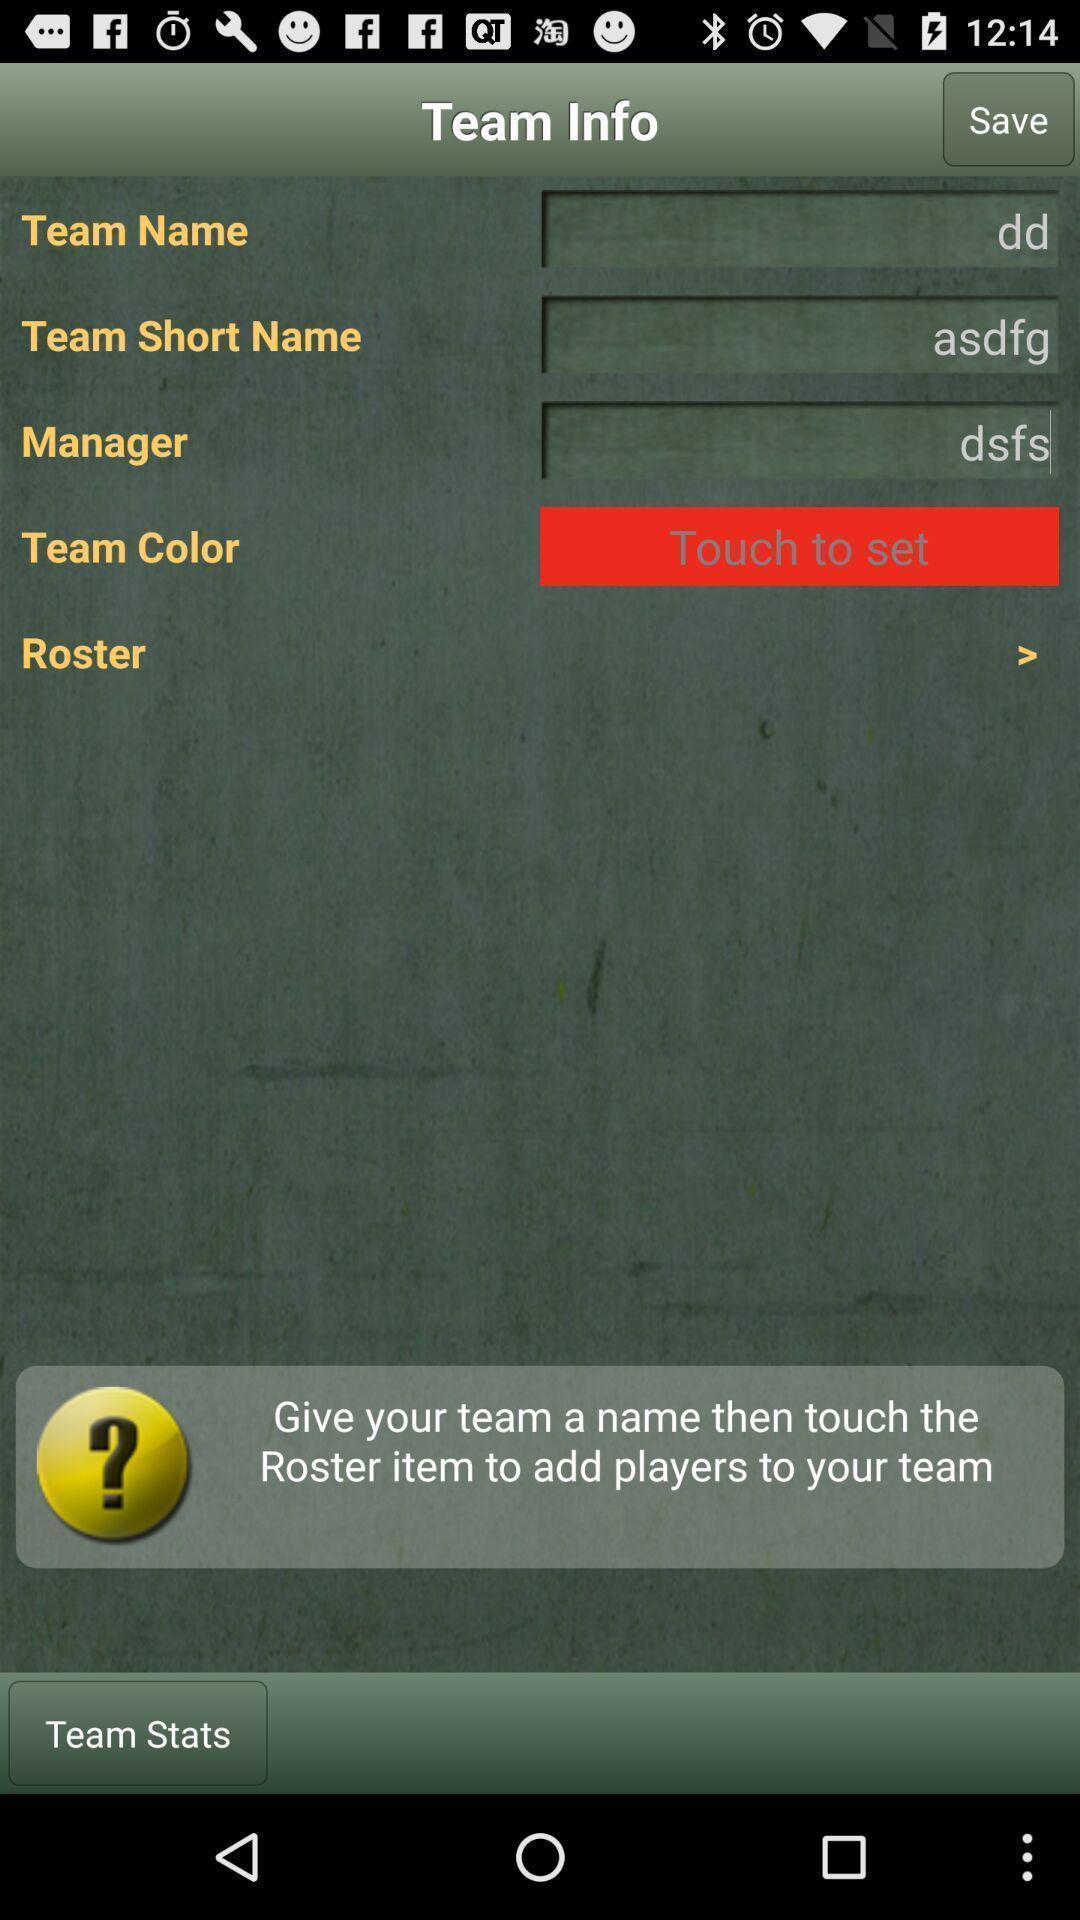Describe the visual elements of this screenshot. Page displaying with team information. 